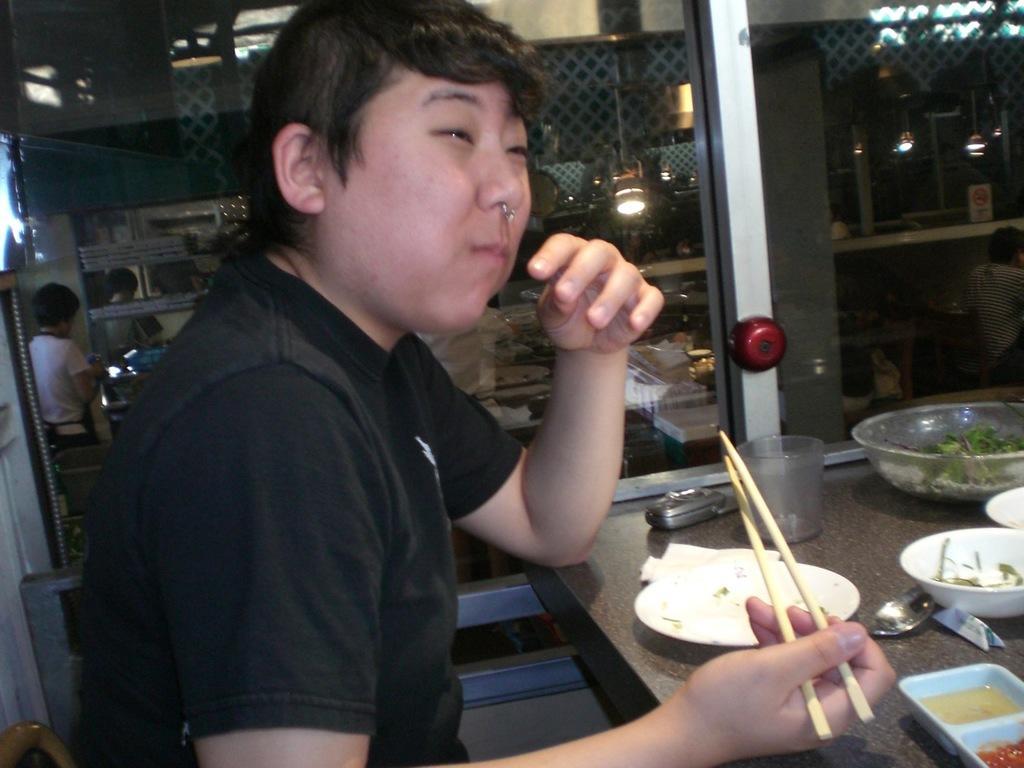Please provide a concise description of this image. In this image I can see a person is holding chopsticks. Here on this table I can see few plates, a phone and a glass. In the background I can see few more people. 